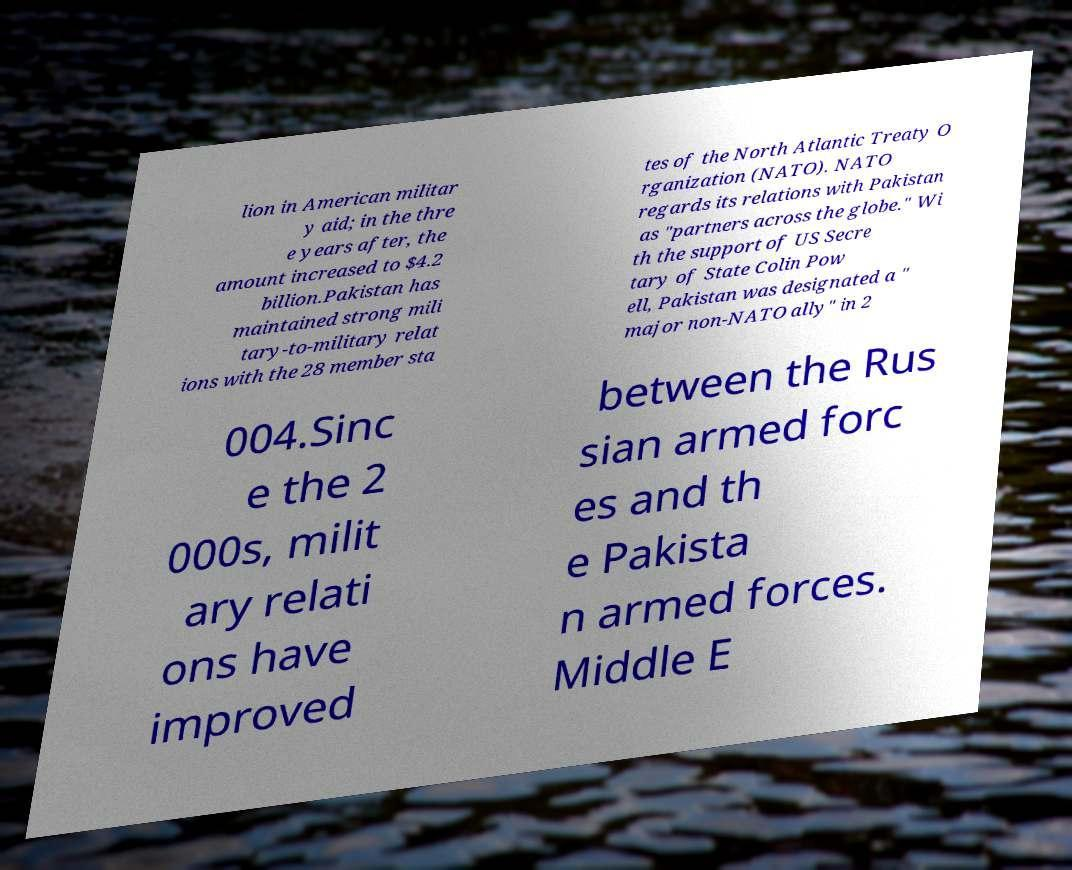I need the written content from this picture converted into text. Can you do that? lion in American militar y aid; in the thre e years after, the amount increased to $4.2 billion.Pakistan has maintained strong mili tary-to-military relat ions with the 28 member sta tes of the North Atlantic Treaty O rganization (NATO). NATO regards its relations with Pakistan as "partners across the globe." Wi th the support of US Secre tary of State Colin Pow ell, Pakistan was designated a " major non-NATO ally" in 2 004.Sinc e the 2 000s, milit ary relati ons have improved between the Rus sian armed forc es and th e Pakista n armed forces. Middle E 